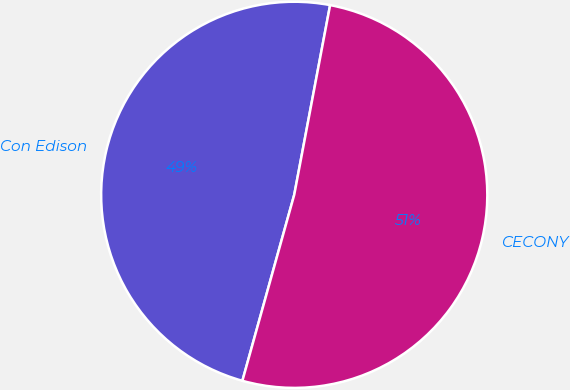<chart> <loc_0><loc_0><loc_500><loc_500><pie_chart><fcel>Con Edison<fcel>CECONY<nl><fcel>48.65%<fcel>51.35%<nl></chart> 